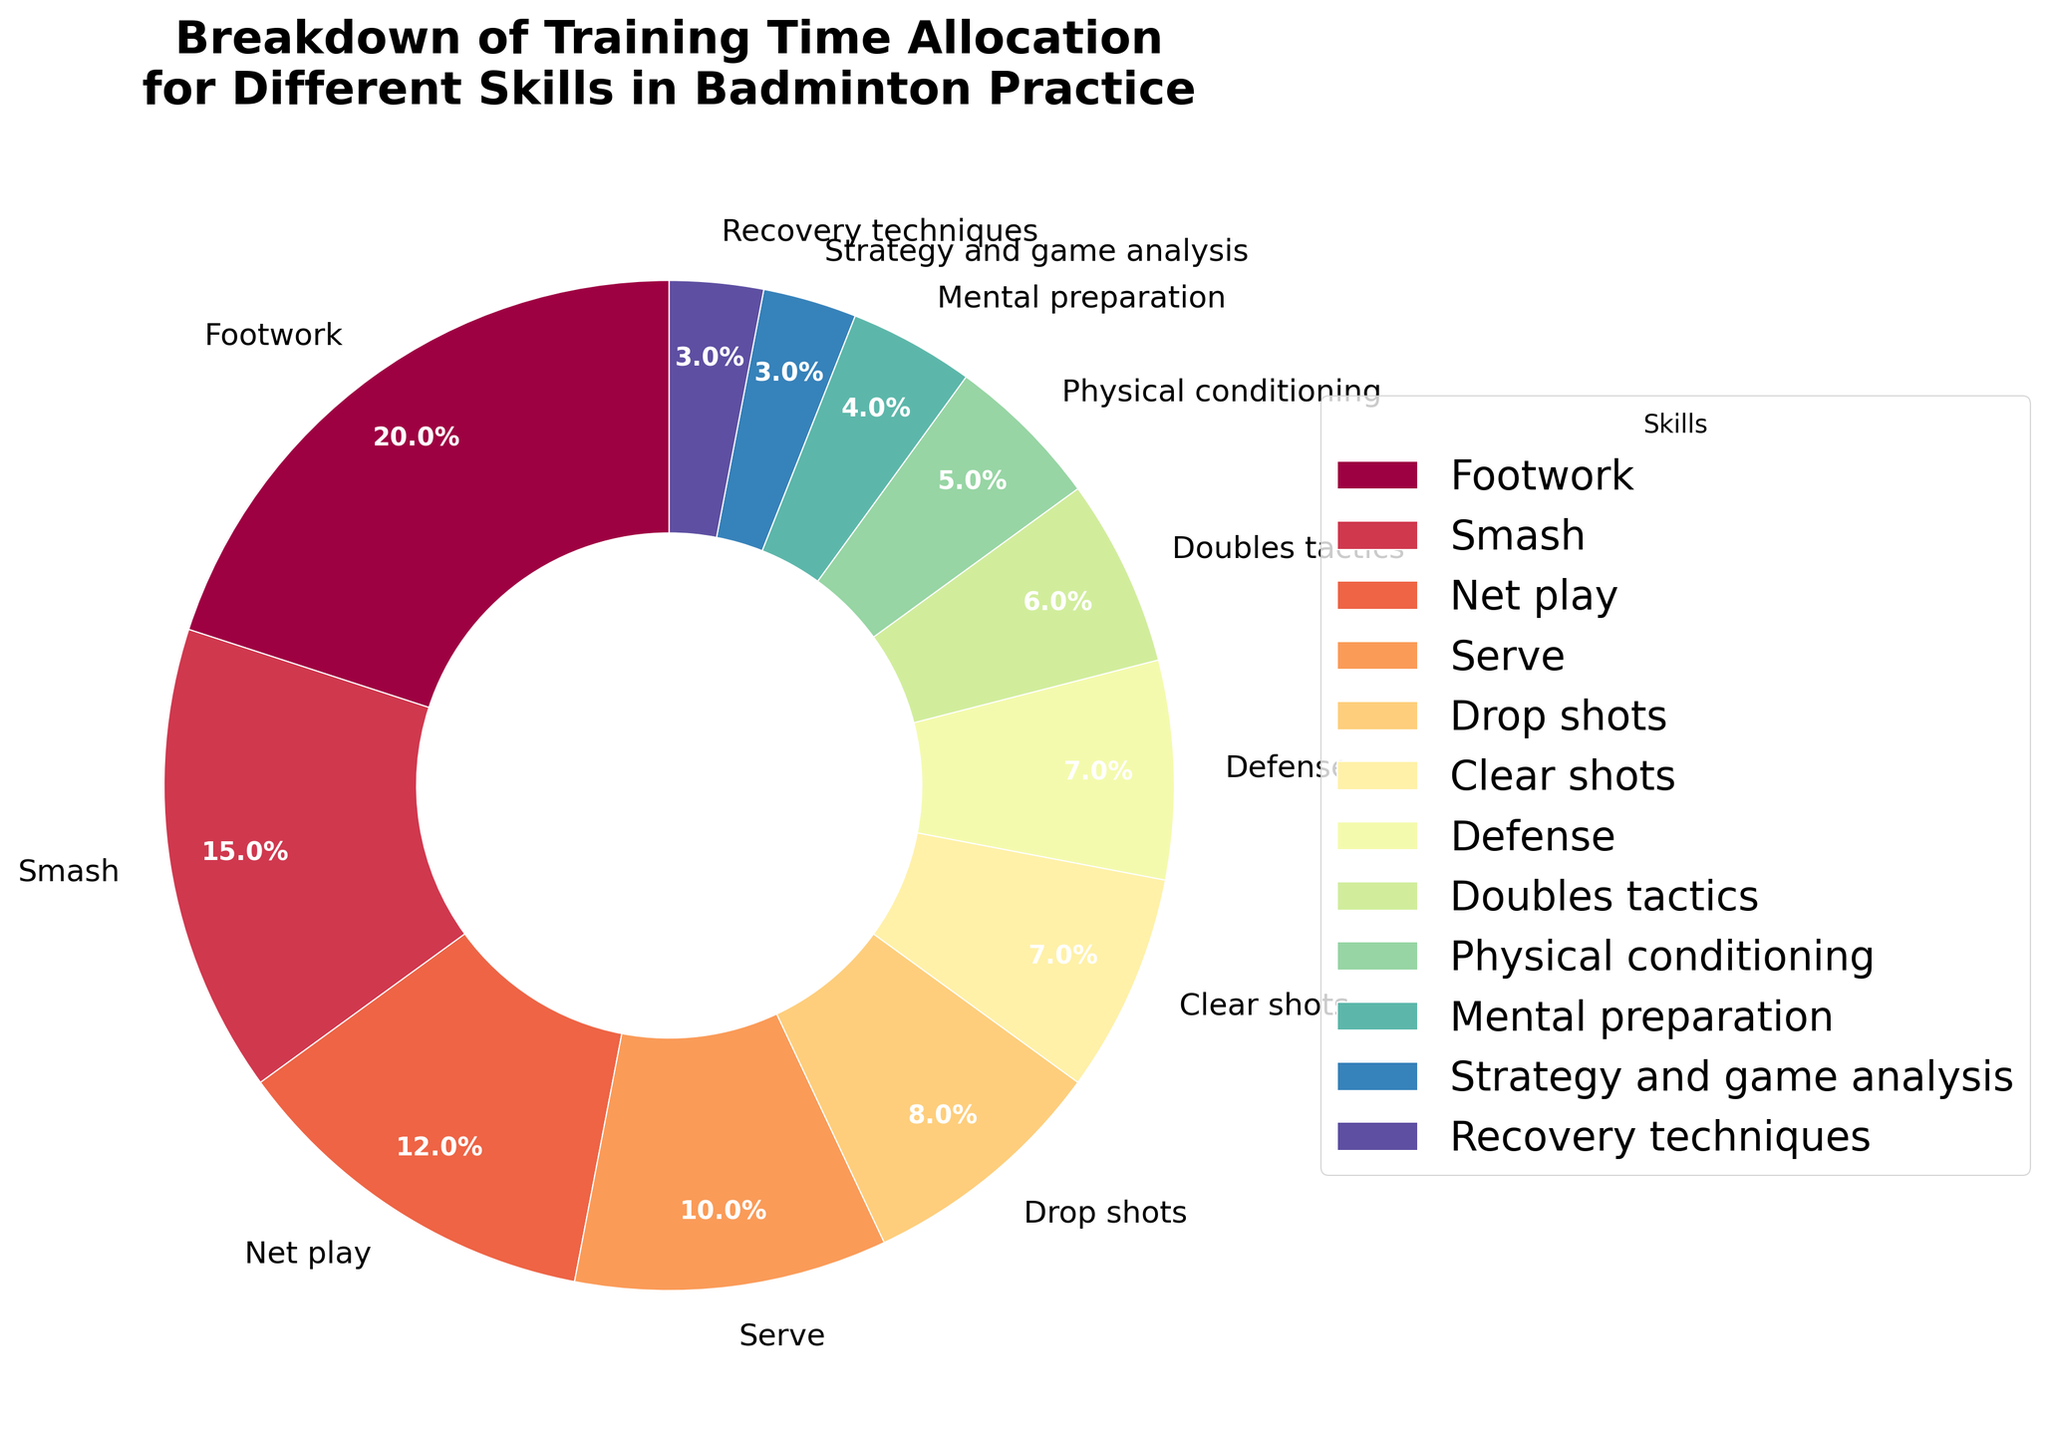Which skill has the highest percentage of training time allocation? By looking at the pie chart, the largest wedge represents Footwork. This is confirmed by the data percentage showing that Footwork has 20%.
Answer: Footwork Which two skills combined take up the same percentage as Smash? Looking at the pie chart, we see Smash takes up 15%. Combining Drop shots (8%) and Net play (7%) results in 15%, which matches.
Answer: Drop shots and Net play What is the visual appearance of the Defense wedge? The Defense wedge in the pie chart appears smaller in size, and its label includes a value of 7%. It is a small, colored wedge near the lower end of the percentages.
Answer: Small, labeled 7% How much more training time is allocated to Footwork than to Strategy and game analysis? Footwork has 20%, and Strategy and game analysis has 3%. The difference is calculated by subtracting 3 from 20.
Answer: 17% What combined percentage of training time is allocated to physical conditioning and mental preparation? According to the pie chart, Physical conditioning is 5% and Mental preparation is 4%. Adding them together gives 9%.
Answer: 9% Which skill has a larger wedge, Serve or Net play? By looking at the chart, the wedge for Serve is 10% and for Net play is 12%. Thus, Net play has a larger wedge.
Answer: Net play What is the total percentage for skills allocated less than 8% of the training time each? According to the chart, Drop shots (8%), Clear shots (7%), Defense (7%), Doubles tactics (6%), Physical conditioning (5%), Mental preparation (4%), Strategy and game analysis (3%), and Recovery techniques (3%) are all less than 8%. Summing them up, we get 8 + 7 + 7 + 6 + 5 + 4 + 3 + 3 = 43%.
Answer: 43% Describe the position and color distribution of the wedge representing Recovery techniques. In the pie chart, the Recovery techniques wedge is a small 3% segment. It's positioned as one of the smallest wedges and will be near the end of the spectrum of colors used, next to other similar low-percentage wedges.
Answer: Small, near the end, and part of a colored spectrum 